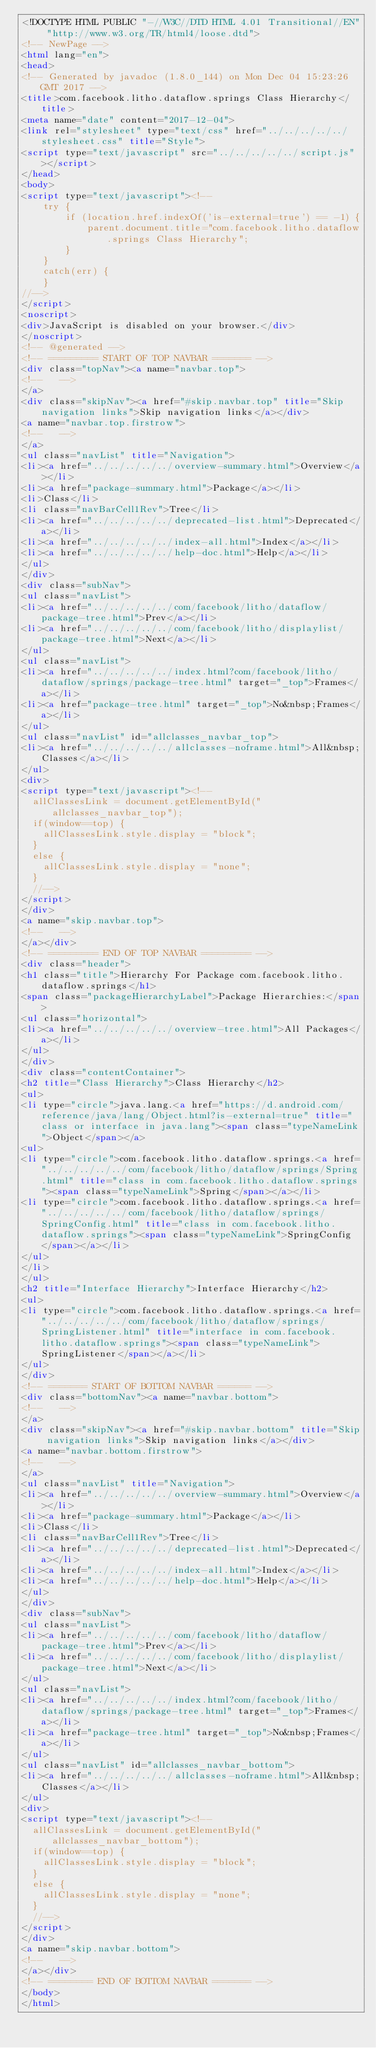<code> <loc_0><loc_0><loc_500><loc_500><_HTML_><!DOCTYPE HTML PUBLIC "-//W3C//DTD HTML 4.01 Transitional//EN" "http://www.w3.org/TR/html4/loose.dtd">
<!-- NewPage -->
<html lang="en">
<head>
<!-- Generated by javadoc (1.8.0_144) on Mon Dec 04 15:23:26 GMT 2017 -->
<title>com.facebook.litho.dataflow.springs Class Hierarchy</title>
<meta name="date" content="2017-12-04">
<link rel="stylesheet" type="text/css" href="../../../../../stylesheet.css" title="Style">
<script type="text/javascript" src="../../../../../script.js"></script>
</head>
<body>
<script type="text/javascript"><!--
    try {
        if (location.href.indexOf('is-external=true') == -1) {
            parent.document.title="com.facebook.litho.dataflow.springs Class Hierarchy";
        }
    }
    catch(err) {
    }
//-->
</script>
<noscript>
<div>JavaScript is disabled on your browser.</div>
</noscript>
<!-- @generated -->
<!-- ========= START OF TOP NAVBAR ======= -->
<div class="topNav"><a name="navbar.top">
<!--   -->
</a>
<div class="skipNav"><a href="#skip.navbar.top" title="Skip navigation links">Skip navigation links</a></div>
<a name="navbar.top.firstrow">
<!--   -->
</a>
<ul class="navList" title="Navigation">
<li><a href="../../../../../overview-summary.html">Overview</a></li>
<li><a href="package-summary.html">Package</a></li>
<li>Class</li>
<li class="navBarCell1Rev">Tree</li>
<li><a href="../../../../../deprecated-list.html">Deprecated</a></li>
<li><a href="../../../../../index-all.html">Index</a></li>
<li><a href="../../../../../help-doc.html">Help</a></li>
</ul>
</div>
<div class="subNav">
<ul class="navList">
<li><a href="../../../../../com/facebook/litho/dataflow/package-tree.html">Prev</a></li>
<li><a href="../../../../../com/facebook/litho/displaylist/package-tree.html">Next</a></li>
</ul>
<ul class="navList">
<li><a href="../../../../../index.html?com/facebook/litho/dataflow/springs/package-tree.html" target="_top">Frames</a></li>
<li><a href="package-tree.html" target="_top">No&nbsp;Frames</a></li>
</ul>
<ul class="navList" id="allclasses_navbar_top">
<li><a href="../../../../../allclasses-noframe.html">All&nbsp;Classes</a></li>
</ul>
<div>
<script type="text/javascript"><!--
  allClassesLink = document.getElementById("allclasses_navbar_top");
  if(window==top) {
    allClassesLink.style.display = "block";
  }
  else {
    allClassesLink.style.display = "none";
  }
  //-->
</script>
</div>
<a name="skip.navbar.top">
<!--   -->
</a></div>
<!-- ========= END OF TOP NAVBAR ========= -->
<div class="header">
<h1 class="title">Hierarchy For Package com.facebook.litho.dataflow.springs</h1>
<span class="packageHierarchyLabel">Package Hierarchies:</span>
<ul class="horizontal">
<li><a href="../../../../../overview-tree.html">All Packages</a></li>
</ul>
</div>
<div class="contentContainer">
<h2 title="Class Hierarchy">Class Hierarchy</h2>
<ul>
<li type="circle">java.lang.<a href="https://d.android.com/reference/java/lang/Object.html?is-external=true" title="class or interface in java.lang"><span class="typeNameLink">Object</span></a>
<ul>
<li type="circle">com.facebook.litho.dataflow.springs.<a href="../../../../../com/facebook/litho/dataflow/springs/Spring.html" title="class in com.facebook.litho.dataflow.springs"><span class="typeNameLink">Spring</span></a></li>
<li type="circle">com.facebook.litho.dataflow.springs.<a href="../../../../../com/facebook/litho/dataflow/springs/SpringConfig.html" title="class in com.facebook.litho.dataflow.springs"><span class="typeNameLink">SpringConfig</span></a></li>
</ul>
</li>
</ul>
<h2 title="Interface Hierarchy">Interface Hierarchy</h2>
<ul>
<li type="circle">com.facebook.litho.dataflow.springs.<a href="../../../../../com/facebook/litho/dataflow/springs/SpringListener.html" title="interface in com.facebook.litho.dataflow.springs"><span class="typeNameLink">SpringListener</span></a></li>
</ul>
</div>
<!-- ======= START OF BOTTOM NAVBAR ====== -->
<div class="bottomNav"><a name="navbar.bottom">
<!--   -->
</a>
<div class="skipNav"><a href="#skip.navbar.bottom" title="Skip navigation links">Skip navigation links</a></div>
<a name="navbar.bottom.firstrow">
<!--   -->
</a>
<ul class="navList" title="Navigation">
<li><a href="../../../../../overview-summary.html">Overview</a></li>
<li><a href="package-summary.html">Package</a></li>
<li>Class</li>
<li class="navBarCell1Rev">Tree</li>
<li><a href="../../../../../deprecated-list.html">Deprecated</a></li>
<li><a href="../../../../../index-all.html">Index</a></li>
<li><a href="../../../../../help-doc.html">Help</a></li>
</ul>
</div>
<div class="subNav">
<ul class="navList">
<li><a href="../../../../../com/facebook/litho/dataflow/package-tree.html">Prev</a></li>
<li><a href="../../../../../com/facebook/litho/displaylist/package-tree.html">Next</a></li>
</ul>
<ul class="navList">
<li><a href="../../../../../index.html?com/facebook/litho/dataflow/springs/package-tree.html" target="_top">Frames</a></li>
<li><a href="package-tree.html" target="_top">No&nbsp;Frames</a></li>
</ul>
<ul class="navList" id="allclasses_navbar_bottom">
<li><a href="../../../../../allclasses-noframe.html">All&nbsp;Classes</a></li>
</ul>
<div>
<script type="text/javascript"><!--
  allClassesLink = document.getElementById("allclasses_navbar_bottom");
  if(window==top) {
    allClassesLink.style.display = "block";
  }
  else {
    allClassesLink.style.display = "none";
  }
  //-->
</script>
</div>
<a name="skip.navbar.bottom">
<!--   -->
</a></div>
<!-- ======== END OF BOTTOM NAVBAR ======= -->
</body>
</html>
</code> 